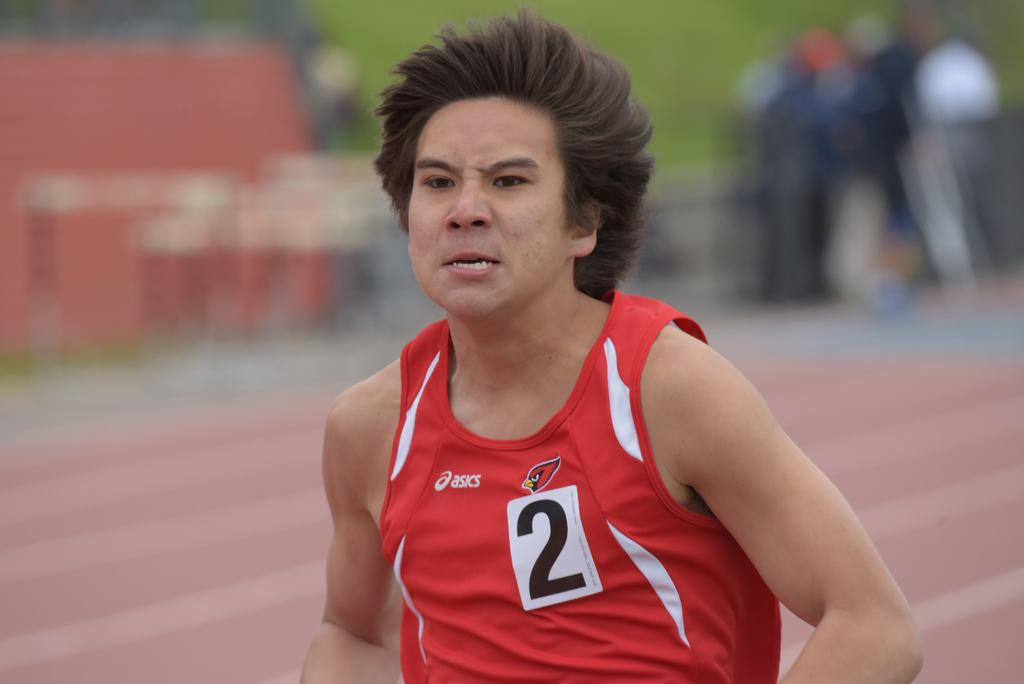<image>
Offer a succinct explanation of the picture presented. A man is running and has the number 2 on his shirt. 